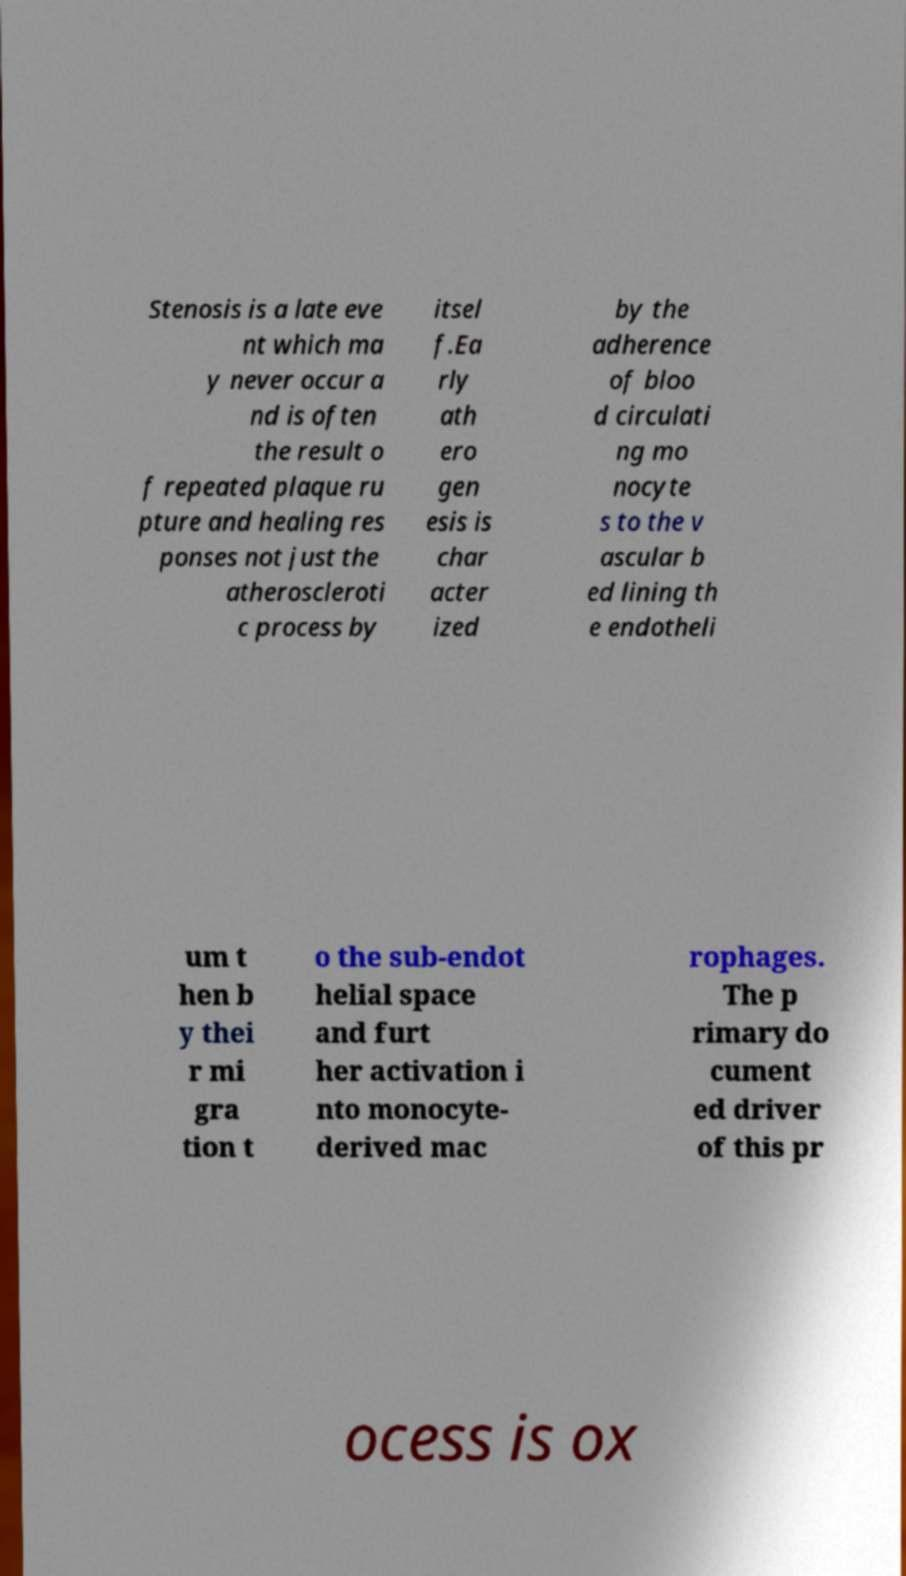Could you extract and type out the text from this image? Stenosis is a late eve nt which ma y never occur a nd is often the result o f repeated plaque ru pture and healing res ponses not just the atheroscleroti c process by itsel f.Ea rly ath ero gen esis is char acter ized by the adherence of bloo d circulati ng mo nocyte s to the v ascular b ed lining th e endotheli um t hen b y thei r mi gra tion t o the sub-endot helial space and furt her activation i nto monocyte- derived mac rophages. The p rimary do cument ed driver of this pr ocess is ox 